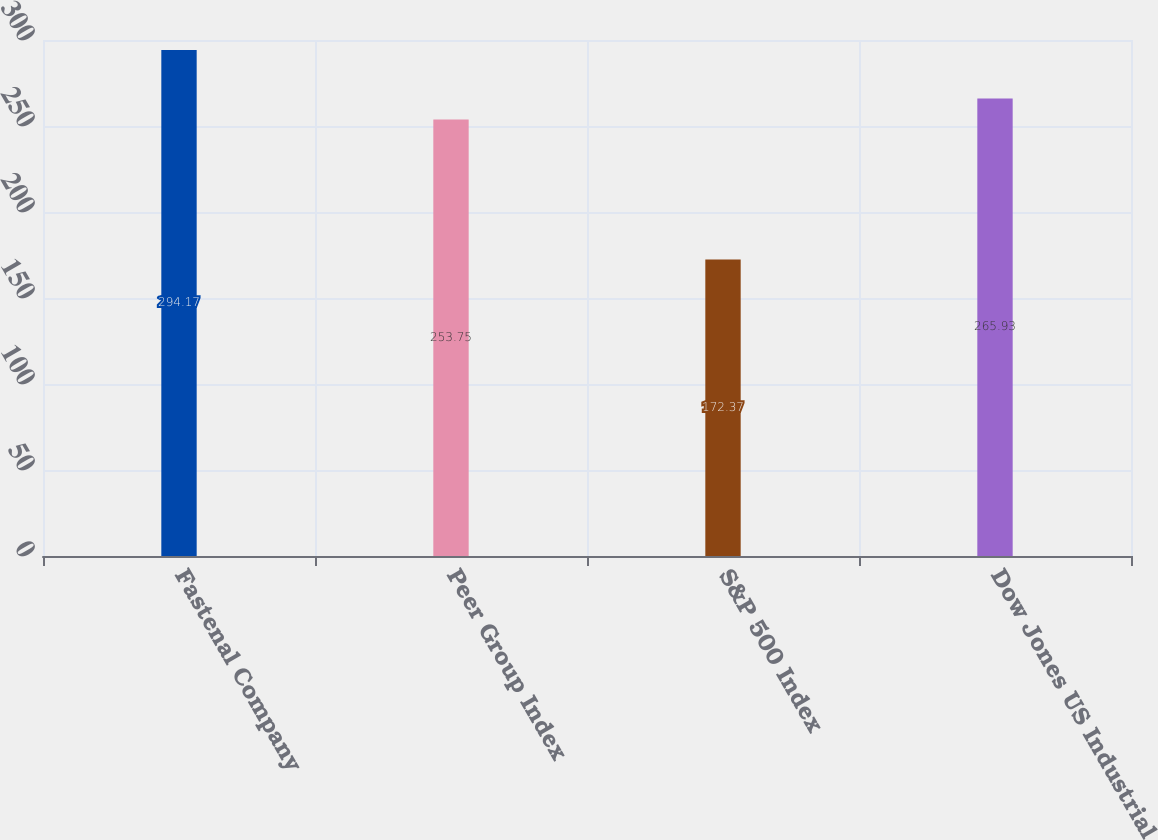<chart> <loc_0><loc_0><loc_500><loc_500><bar_chart><fcel>Fastenal Company<fcel>Peer Group Index<fcel>S&P 500 Index<fcel>Dow Jones US Industrial<nl><fcel>294.17<fcel>253.75<fcel>172.37<fcel>265.93<nl></chart> 